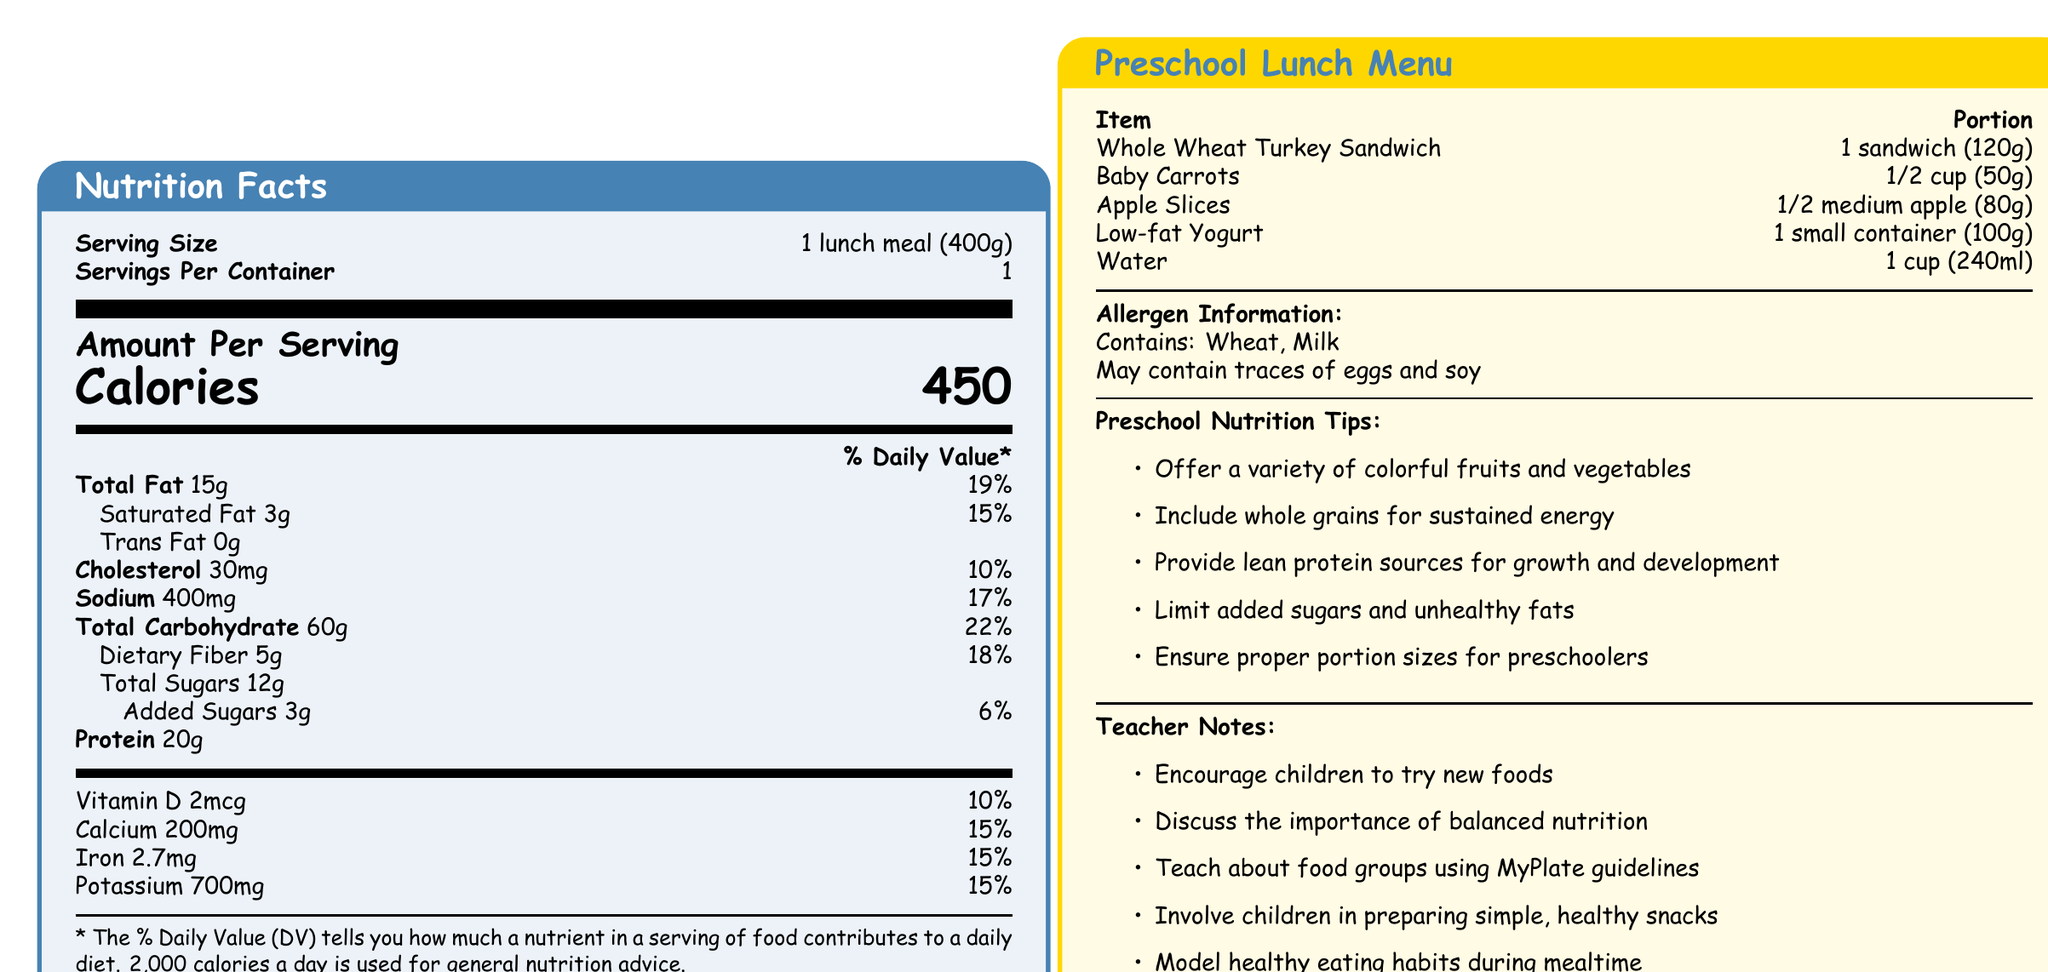What is the serving size for the lunch meal? The serving size is explicitly stated at the beginning of the nutritional information.
Answer: 1 lunch meal (400g) How many calories are in the entire lunch meal? The calories per serving are listed as 450.
Answer: 450 calories What is the amount of saturated fat in the lunch meal? The amount of saturated fat is listed under the total fat information.
Answer: 3g What percentage of the daily value for sodium does the lunch meal provide? The percent daily value for sodium is listed as 17%.
Answer: 17% Which menu item contains wheat? The allergen information indicates that the meal contains wheat, implicating the Whole Wheat Turkey Sandwich.
Answer: Whole Wheat Turkey Sandwich How much protein is in the lunch meal? The amount of protein is listed directly on the nutrition facts table.
Answer: 20g What is the portion size for Low-fat Yogurt? This portion size is provided in the lunch menu section under meal items.
Answer: 1 small container (100g) How much calcium is in the lunch meal? The amount of calcium is listed in the vitamins and minerals section.
Answer: 200mg Which nutrient in the lunch meal has the highest daily value percentage? A. Total Fat B. Total Carbohydrate C. Dietary Fiber D. Vitamin D Total Carbohydrate has a daily value percentage of 22%, which is the highest among the listed nutrients.
Answer: B. Total Carbohydrate Which menu item is the largest by portion weight? A. Whole Wheat Turkey Sandwich B. Baby Carrots C. Apple Slices D. Water The portion for water is 240ml which is equivalent roughly to 240g, the largest among the listed items.
Answer: D. Water Does the lunch meal contain any trans fat? The nutritional facts state that the trans fat content is 0g.
Answer: No Summarize the main components and information presented in the document. The document includes thorough information to inform about the nutrition, portion sizes, and considerations for preparing a balanced and healthy meal for preschoolers.
Answer: The document provides nutrition facts for a balanced preschool lunch menu, detailing serving sizes, nutrient content, and daily value percentages for various nutrients. The lunch menu includes items like a whole wheat turkey sandwich, baby carrots, apple slices, low-fat yogurt, and water. It also includes allergen information, preschool nutrition tips, and notes for teachers. What fruit is included in the lunch menu? The fruit listed in the menu items is apple slices.
Answer: Apple Slices Does the lunch meal provide more than 10% of the daily value for potassium? The lunch meal provides 15% of the daily value for potassium.
Answer: Yes What are two ways teachers can encourage healthy eating habits according to the document? These ways are listed under the teacher notes section.
Answer: Encourage children to try new foods and involve children in preparing simple, healthy snacks How much added sugar is in the lunch meal? The amount of added sugars is listed in the nutritional facts.
Answer: 3g Calculate the total weight of the lunch menu items provided (excluding the water). Adding the weights: 120g (sandwich) + 50g (baby carrots) + 80g (apple slices) + 100g (yogurt) = 350g.
Answer: 350g Which vitamin is listed with a daily value percentage? A. Vitamin D B. Vitamin C C. Vitamin B12 D. Vitamin A The vitamin listed with a daily value percentage is Vitamin D, with a daily value percentage of 10%.
Answer: A. Vitamin D Which food group should be limited according to the preschool nutrition tips? The preschool nutrition tips explicitly suggest to limit added sugars and unhealthy fats.
Answer: Added sugars and unhealthy fats Can we determine the exact ingredients of the whole wheat turkey sandwich from the document? The document lists the name and portion size of the item but does not detail the specific ingredients.
Answer: No 